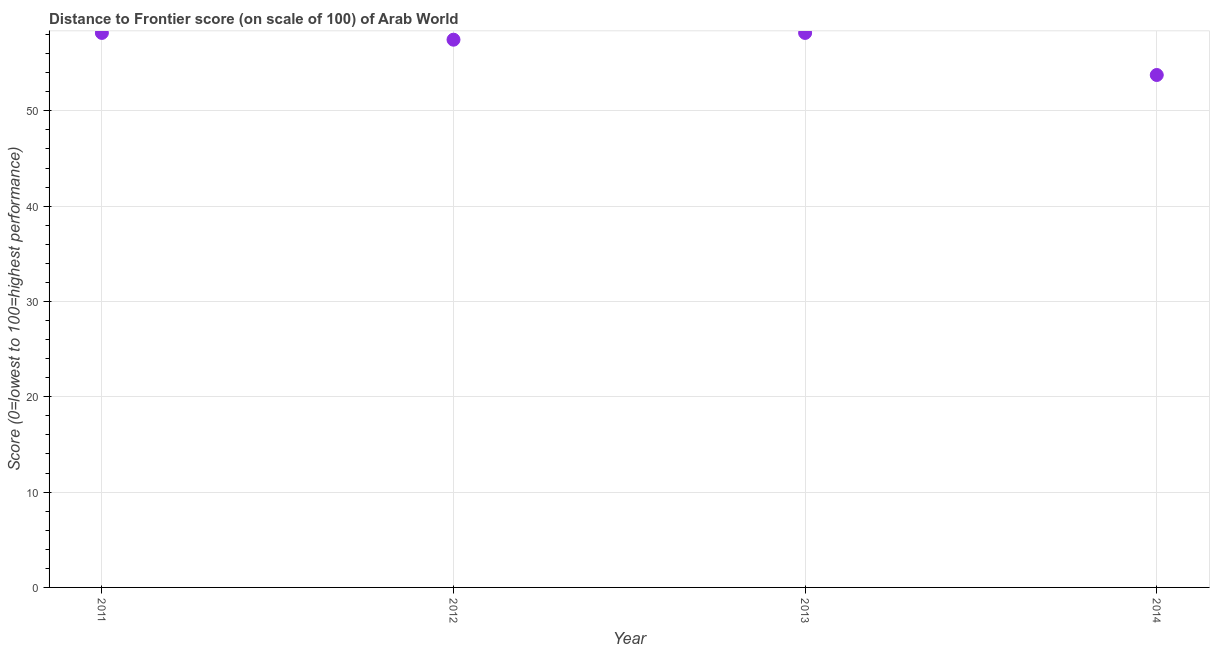What is the distance to frontier score in 2011?
Your response must be concise. 58.18. Across all years, what is the maximum distance to frontier score?
Give a very brief answer. 58.18. Across all years, what is the minimum distance to frontier score?
Offer a terse response. 53.76. In which year was the distance to frontier score minimum?
Provide a short and direct response. 2014. What is the sum of the distance to frontier score?
Offer a terse response. 227.58. What is the difference between the distance to frontier score in 2012 and 2013?
Ensure brevity in your answer.  -0.71. What is the average distance to frontier score per year?
Provide a short and direct response. 56.9. What is the median distance to frontier score?
Keep it short and to the point. 57.82. Do a majority of the years between 2011 and 2013 (inclusive) have distance to frontier score greater than 34 ?
Offer a very short reply. Yes. What is the ratio of the distance to frontier score in 2013 to that in 2014?
Your answer should be very brief. 1.08. Is the distance to frontier score in 2012 less than that in 2014?
Offer a very short reply. No. What is the difference between the highest and the second highest distance to frontier score?
Your answer should be very brief. 0. What is the difference between the highest and the lowest distance to frontier score?
Your answer should be very brief. 4.41. In how many years, is the distance to frontier score greater than the average distance to frontier score taken over all years?
Provide a succinct answer. 3. Does the distance to frontier score monotonically increase over the years?
Your response must be concise. No. How many years are there in the graph?
Give a very brief answer. 4. What is the difference between two consecutive major ticks on the Y-axis?
Your response must be concise. 10. Does the graph contain any zero values?
Ensure brevity in your answer.  No. What is the title of the graph?
Your answer should be very brief. Distance to Frontier score (on scale of 100) of Arab World. What is the label or title of the Y-axis?
Offer a terse response. Score (0=lowest to 100=highest performance). What is the Score (0=lowest to 100=highest performance) in 2011?
Provide a short and direct response. 58.18. What is the Score (0=lowest to 100=highest performance) in 2012?
Your response must be concise. 57.47. What is the Score (0=lowest to 100=highest performance) in 2013?
Give a very brief answer. 58.18. What is the Score (0=lowest to 100=highest performance) in 2014?
Offer a very short reply. 53.76. What is the difference between the Score (0=lowest to 100=highest performance) in 2011 and 2012?
Your response must be concise. 0.71. What is the difference between the Score (0=lowest to 100=highest performance) in 2011 and 2013?
Make the answer very short. 0. What is the difference between the Score (0=lowest to 100=highest performance) in 2011 and 2014?
Provide a succinct answer. 4.41. What is the difference between the Score (0=lowest to 100=highest performance) in 2012 and 2013?
Give a very brief answer. -0.71. What is the difference between the Score (0=lowest to 100=highest performance) in 2012 and 2014?
Offer a terse response. 3.7. What is the difference between the Score (0=lowest to 100=highest performance) in 2013 and 2014?
Offer a terse response. 4.41. What is the ratio of the Score (0=lowest to 100=highest performance) in 2011 to that in 2012?
Your answer should be compact. 1.01. What is the ratio of the Score (0=lowest to 100=highest performance) in 2011 to that in 2014?
Give a very brief answer. 1.08. What is the ratio of the Score (0=lowest to 100=highest performance) in 2012 to that in 2013?
Keep it short and to the point. 0.99. What is the ratio of the Score (0=lowest to 100=highest performance) in 2012 to that in 2014?
Provide a succinct answer. 1.07. What is the ratio of the Score (0=lowest to 100=highest performance) in 2013 to that in 2014?
Keep it short and to the point. 1.08. 